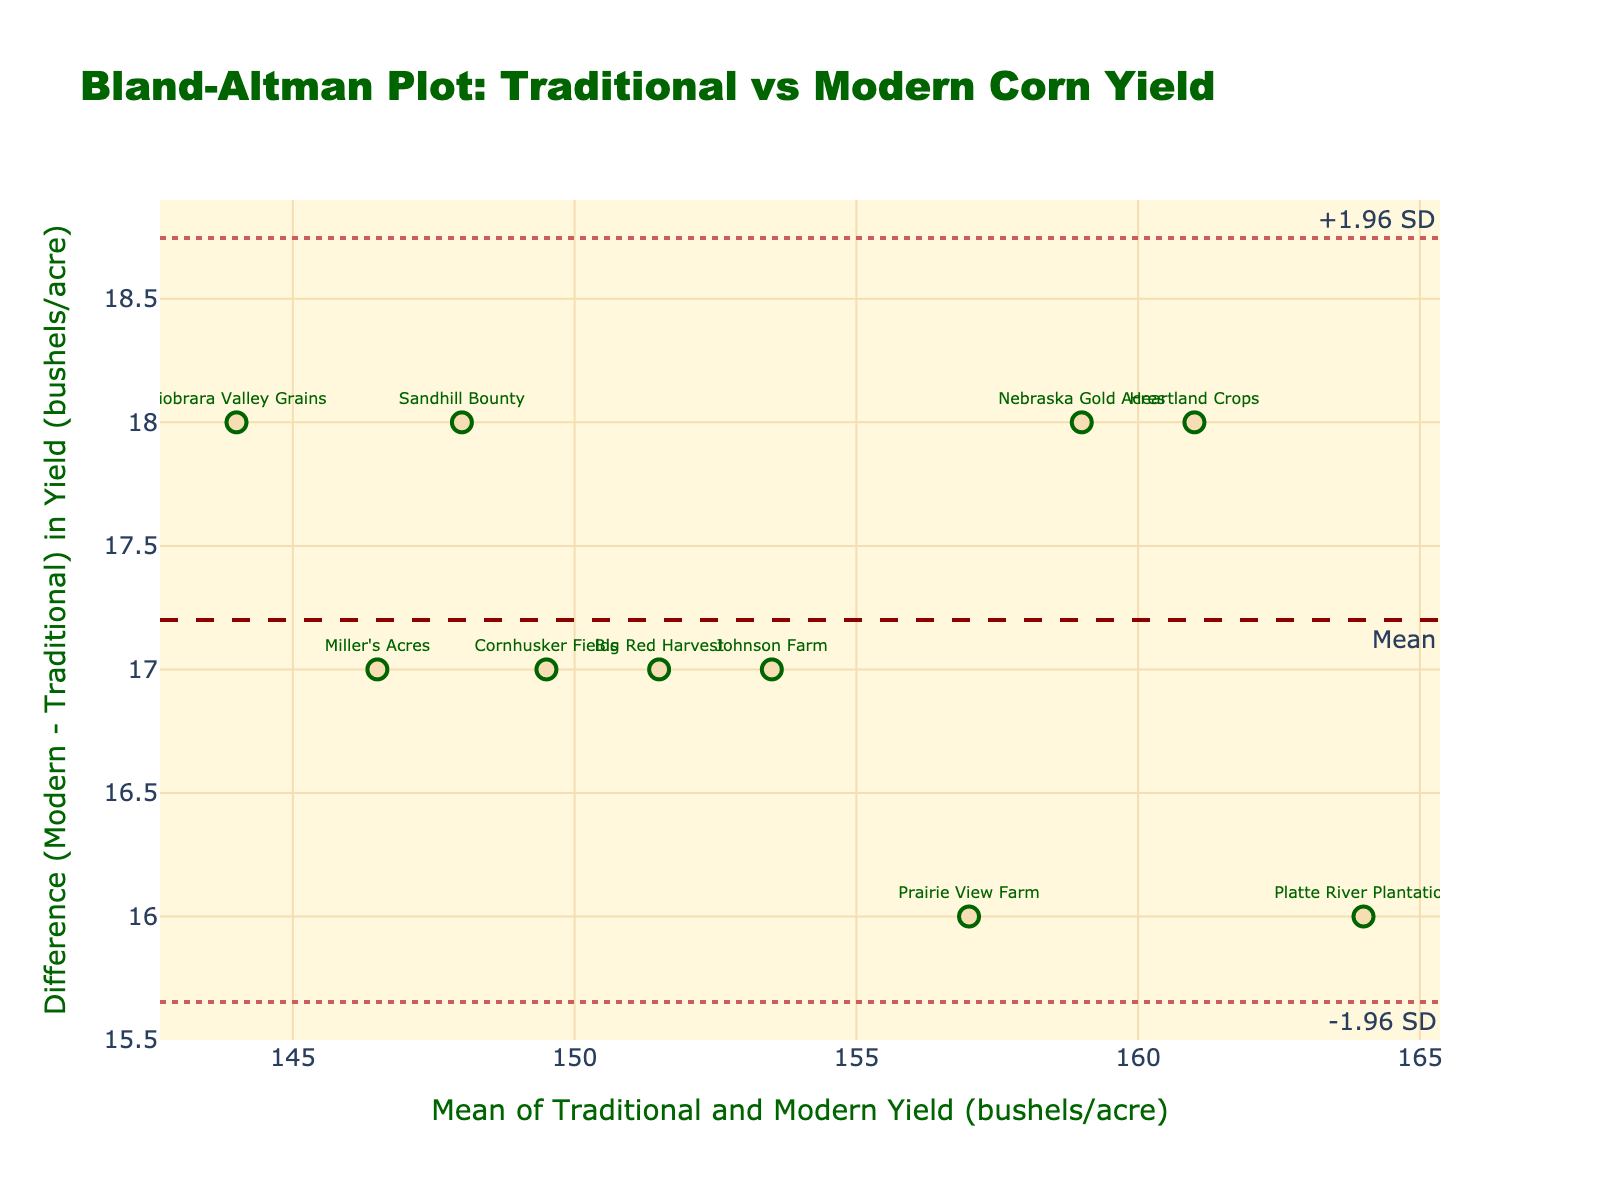What's the title of the plot? The title is usually found at the top of the plot, summarizing what the plot is about in a few words
Answer: Bland-Altman Plot: Traditional vs Modern Corn Yield What are the labels of the x-axis and y-axis? The x-axis and y-axis titles are located adjacent to the respective axes, describing what each axis represents
Answer: Mean of Traditional and Modern Yield (bushels/acre), Difference (Modern - Traditional) in Yield (bushels/acre) How many farmers are represented in the plot? By counting the individual data points with text annotations for each farmer's name, you can determine the number of represented farmers
Answer: 10 What's the mean difference (Modern - Traditional) in yield? This value is usually indicated by a dashed horizontal line labeled 'Mean' on a Bland-Altman plot, representing the central tendency of the differences
Answer: 16.1 What are the limits of agreement in this plot? Limits of agreement are typically shown as dotted horizontal lines at ±1.96 standard deviations from the mean difference, labeled on the plot
Answer: -1.92, 34.12 What is the highest modern yield reported and who achieved it? Compare individual yields visually, locating the highest data point on the Modern_Yield axis, then referencing the farmer's name
Answer: Platte River Plantation with 172 bushels/acre Is there any farmer whose traditional and modern yields are identical? Look for any data point that would lie on the zero difference line (y-axis = 0), meaning no difference in yields
Answer: None Which farm shows the greatest increase in yield using modern techniques versus traditional methods? Identify the data point with the largest positive difference (y-axis), indicating the greatest increase in yield
Answer: Platte River Plantation Which data point represents the smallest difference between traditional and modern yields? Locate the data point closest to the mean difference line or with the smallest vertical distance from the x-axis
Answer: Niobrara Valley Grains Does any farmer show a negative difference between modern and traditional yields? Check for data points located below the x-axis, which would indicate a negative difference (i.e., modern yield less than traditional yield)
Answer: None 